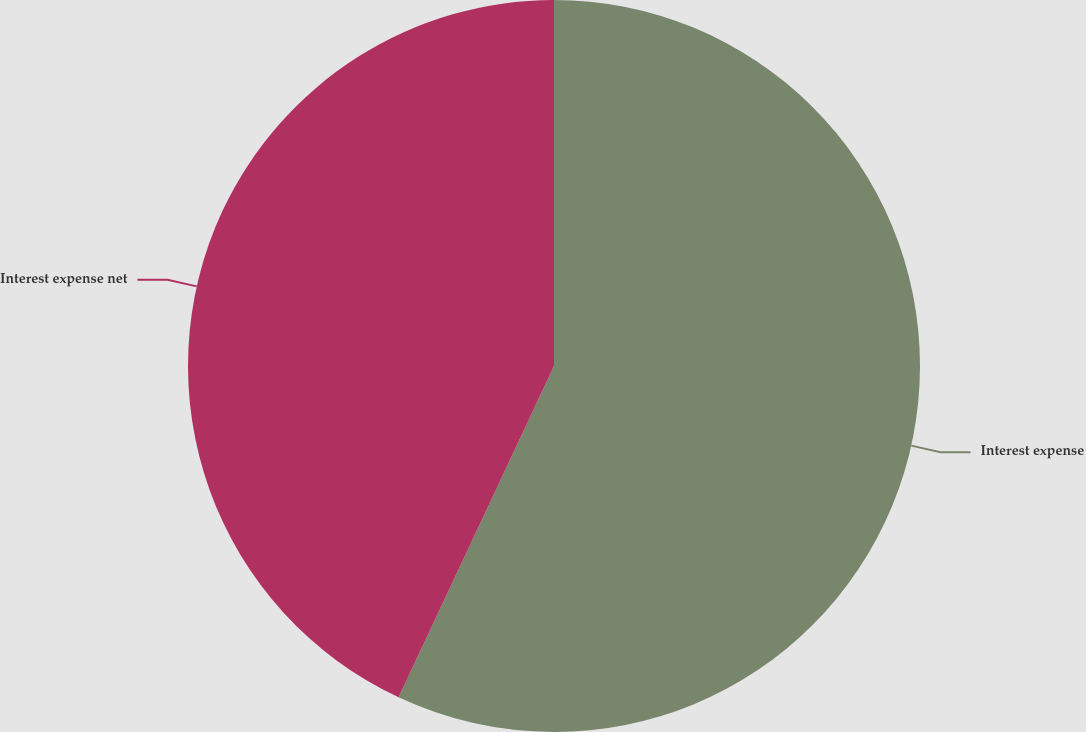<chart> <loc_0><loc_0><loc_500><loc_500><pie_chart><fcel>Interest expense<fcel>Interest expense net<nl><fcel>56.98%<fcel>43.02%<nl></chart> 